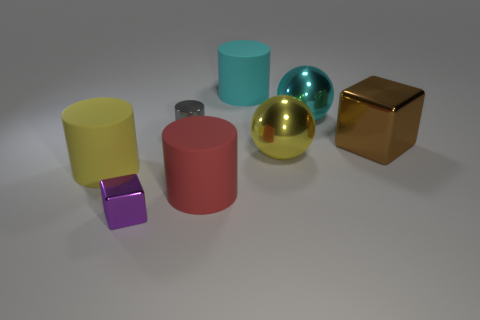What is the color of the large matte cylinder behind the small metallic thing on the right side of the purple object?
Offer a very short reply. Cyan. The small metal thing that is the same shape as the big cyan rubber thing is what color?
Offer a very short reply. Gray. The cyan object that is the same shape as the big yellow metal object is what size?
Your answer should be compact. Large. There is a big ball that is behind the brown thing; what is its material?
Your answer should be compact. Metal. Are there fewer shiny spheres behind the big brown block than matte cylinders?
Provide a short and direct response. Yes. What is the shape of the small metal thing that is in front of the cube behind the tiny purple cube?
Your answer should be very brief. Cube. The small shiny block is what color?
Ensure brevity in your answer.  Purple. What number of other objects are the same size as the cyan metal sphere?
Your answer should be compact. 5. There is a big cylinder that is both in front of the big block and to the right of the purple metal cube; what is its material?
Give a very brief answer. Rubber. Is the size of the rubber cylinder that is on the right side of the red thing the same as the large brown shiny thing?
Make the answer very short. Yes. 